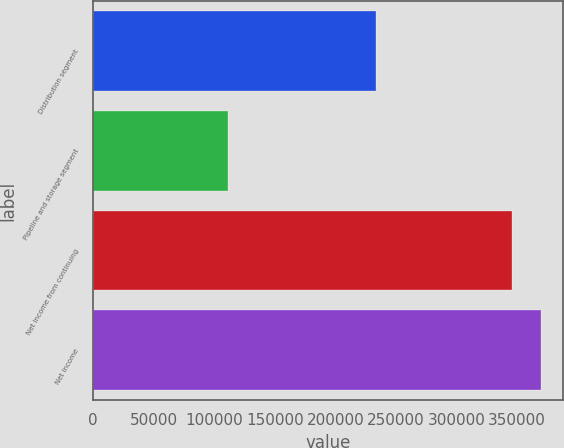Convert chart to OTSL. <chart><loc_0><loc_0><loc_500><loc_500><bar_chart><fcel>Distribution segment<fcel>Pipeline and storage segment<fcel>Net income from continuing<fcel>Net income<nl><fcel>233830<fcel>111712<fcel>345542<fcel>369381<nl></chart> 